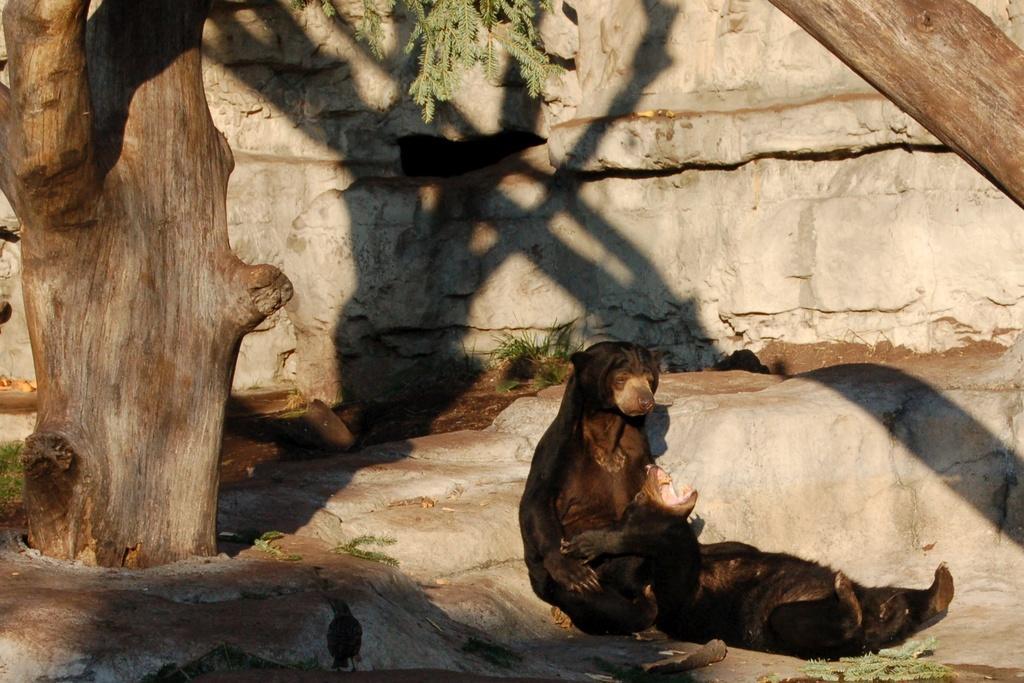How would you summarize this image in a sentence or two? In this picture we can see there are two animals and a bird on the path. Behind the animals there are tree trunks, leaves and a wall. 